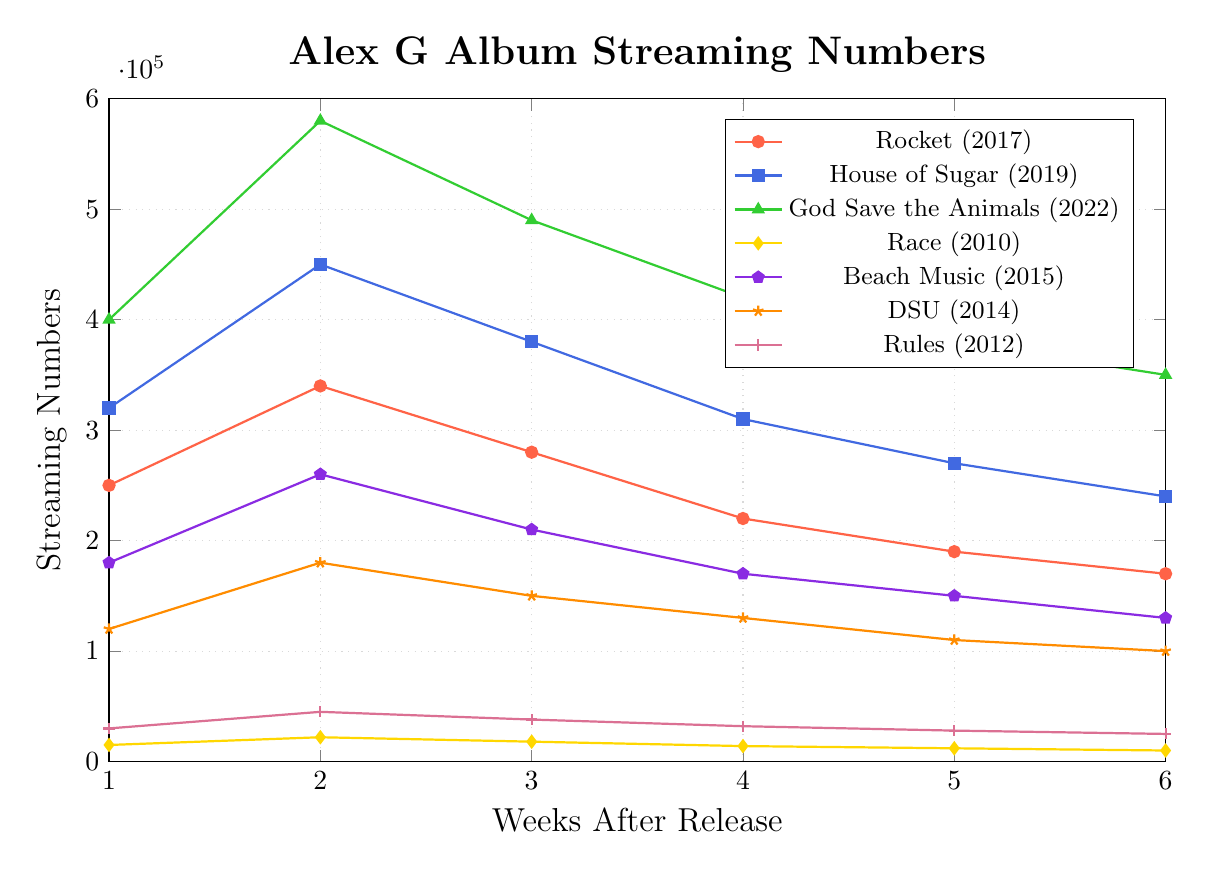What is the peak streaming number for the album "House of Sugar"? Look at the highest point on the "House of Sugar" line, representing its peak streaming numbers in thousands. The peak is at 450,000 in the second week.
Answer: 450,000 Which album had the lowest streaming numbers in its first week? Compare the starting points of all lines, corresponding to the first week's streaming numbers. "Race" has the lowest first-week streaming numbers with 15,000.
Answer: Race By how much did the streaming numbers for "Rocket" decrease from Week 2 to Week 4? Find the streaming numbers for "Rocket" in Week 2 (340,000) and Week 4 (220,000). Subtract Week 4 from Week 2: 340,000 - 220,000 = 120,000.
Answer: 120,000 Which album shows the most significant drop in streaming numbers from Week 1 to Week 2? Compare the drops by calculating the differences between Week 1 and Week 2 for all albums. "Rocket" dropped from 250,000 to 340,000, a drop of 90,000; "House of Sugar" by 130,000; "God Save the Animals" by 180,000; "Race" by 7,000; "Beach Music" by 80,000; "DSU" by 60,000; "Rules" by 15,000. Thus, "God Save the Animals" shows the most significant drop.
Answer: God Save the Animals What is the average streaming number for "DSU" over the six weeks? Sum the streaming numbers of "DSU" over six weeks and divide by 6. (120,000 + 180,000 + 150,000 + 130,000 + 110,000 + 100,000) / 6 = 790,000 / 6 = 131,666.67.
Answer: 131,666.67 Which album maintained the highest average streaming numbers over the six weeks? Calculate the average streaming numbers for all albums and compare. "Rocket": 241,667, "House of Sugar": 328,333, "God Save the Animals": 436,667, "Race": 15,833, "Beach Music": 183,333, "DSU": 131,667, "Rules": 33,000. Thus, "God Save the Animals" maintained the highest average.
Answer: God Save the Animals How do the Week 3 streaming numbers for "Rocket" and "Beach Music" compare? Look at the Week 3 streaming numbers for both albums. "Rocket" has 280,000 and "Beach Music" has 210,000. Compare the two, indicating that "Rocket" has higher Week 3 streaming numbers.
Answer: Rocket's numbers are higher What is the total sum of streaming numbers for "Rules" over the six weeks? Add the streaming numbers of "Rules" over six weeks. 30,000 + 45,000 + 38,000 + 32,000 + 28,000 + 25,000 = 198,000.
Answer: 198,000 For which albums did the streaming numbers decrease every week over the six weeks? Check each album's weekly streaming numbers and identify those that consistently decrease. "Rocket" (250,000 to 170,000), "House of Sugar" (320,000 to 240,000), "God Save the Animals" (400,000 to 350,000), "Beach Music" (180,000 to 130,000), and "DSU" (120,000 to 100,000) all meet this criterion.
Answer: Rocket, House of Sugar, God Save the Animals, Beach Music, DSU What is the main color used to represent "Race" in the plot? Identify the color of the line corresponding to "Race" in the line chart. "Race" is represented by yellow.
Answer: Yellow 